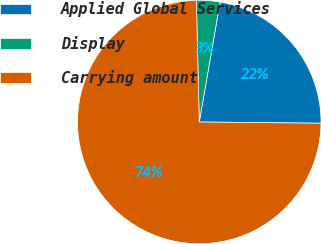<chart> <loc_0><loc_0><loc_500><loc_500><pie_chart><fcel>Applied Global Services<fcel>Display<fcel>Carrying amount<nl><fcel>22.42%<fcel>3.12%<fcel>74.46%<nl></chart> 